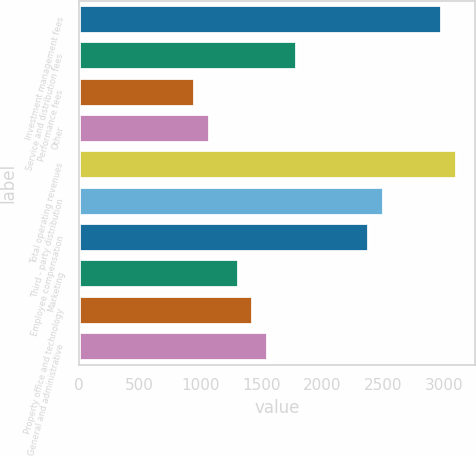<chart> <loc_0><loc_0><loc_500><loc_500><bar_chart><fcel>Investment management fees<fcel>Service and distribution fees<fcel>Performance fees<fcel>Other<fcel>Total operating revenues<fcel>Third - party distribution<fcel>Employee compensation<fcel>Marketing<fcel>Property office and technology<fcel>General and administrative<nl><fcel>2986.28<fcel>1791.88<fcel>955.8<fcel>1075.24<fcel>3105.72<fcel>2508.52<fcel>2389.08<fcel>1314.12<fcel>1433.56<fcel>1553<nl></chart> 